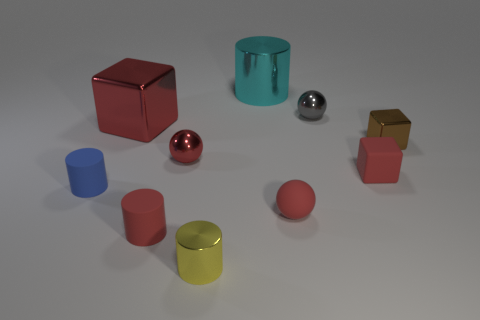There is a tiny block that is in front of the brown metal thing; what number of small red things are on the right side of it?
Keep it short and to the point. 0. Are the small block on the left side of the brown cube and the yellow cylinder made of the same material?
Give a very brief answer. No. What size is the red cube left of the tiny red ball that is in front of the small blue object?
Give a very brief answer. Large. There is a red rubber thing that is left of the shiny cylinder in front of the red block that is to the right of the cyan shiny object; how big is it?
Offer a very short reply. Small. Does the small blue rubber object on the left side of the tiny gray ball have the same shape as the small red matte thing that is left of the small rubber ball?
Provide a succinct answer. Yes. What number of other objects are there of the same color as the tiny rubber ball?
Ensure brevity in your answer.  4. There is a sphere to the left of the yellow cylinder; does it have the same size as the brown shiny block?
Offer a very short reply. Yes. Does the big thing that is to the left of the cyan thing have the same material as the small brown object that is behind the blue object?
Keep it short and to the point. Yes. Are there any blocks that have the same size as the cyan cylinder?
Your answer should be very brief. Yes. What shape is the big metallic object that is right of the small sphere that is on the left side of the metal cylinder that is behind the small gray metal object?
Ensure brevity in your answer.  Cylinder. 